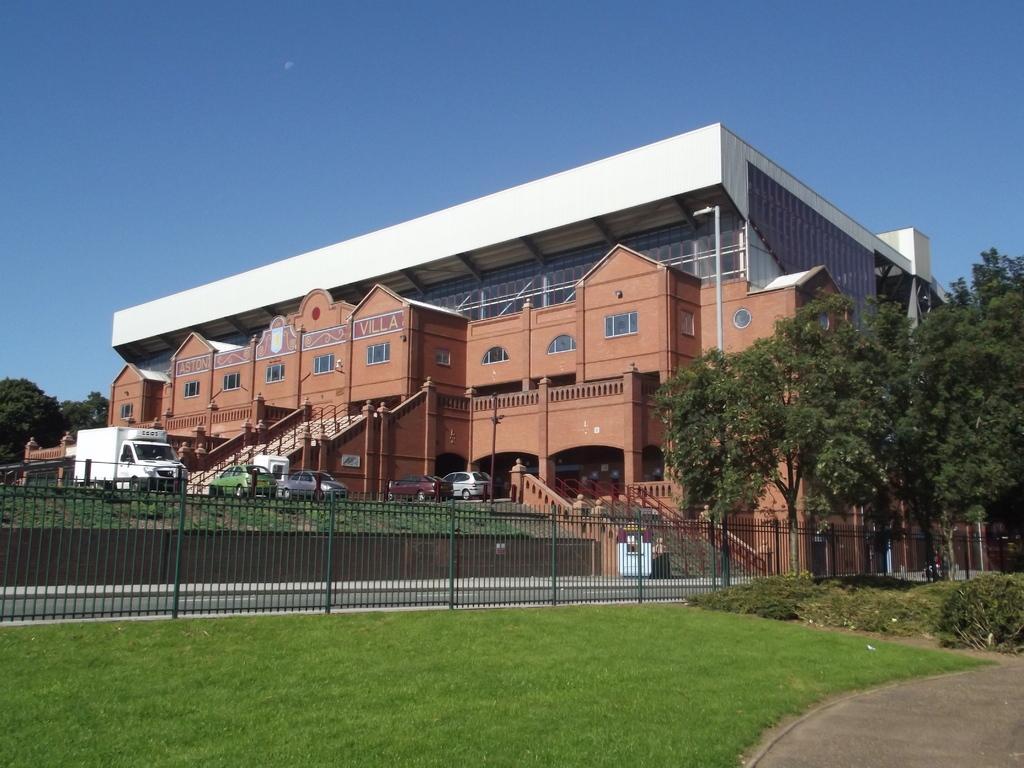How would you summarize this image in a sentence or two? In this image I can see the railing, few vehicles, trees in green color and I can also see the building in brown color and the sky is in blue color. 